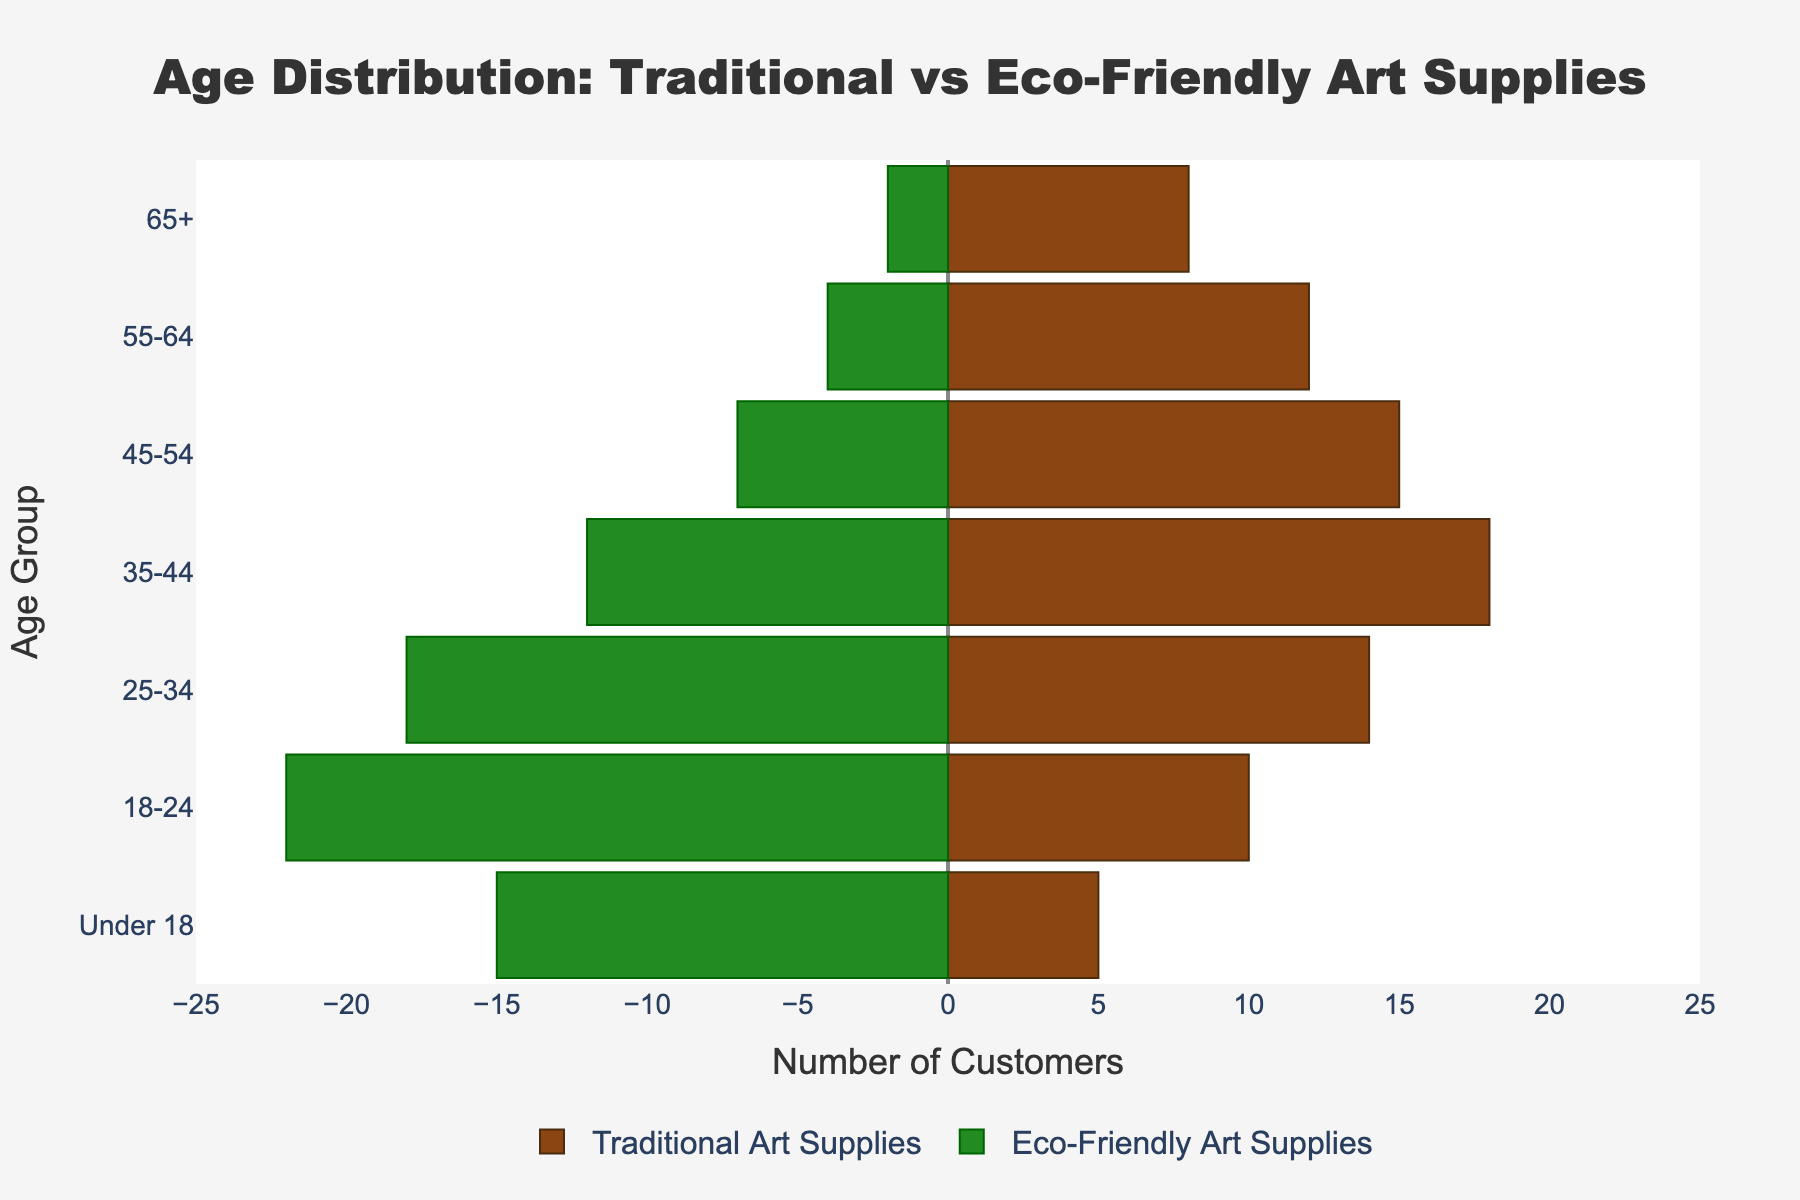What's the title of the figure? The title is centered at the top of the figure and is typically the most prominent text. It is a few words long, generally summarizes what the chart represents.
Answer: Age Distribution: Traditional vs Eco-Friendly Art Supplies How many customers under 18 buy eco-friendly art supplies? The figure shows a bar on the left side for the age group under 18. The height of the bar corresponds to the number of customers in that age group.
Answer: 15 Which age group has the most traditional art supply customers? We need to compare the lengths of the bars on the right side of the figure for different age groups and identify the longest one.
Answer: 35-44 How many more eco-friendly art supply customers are there in the 25-34 age group compared to traditional art supply customers? From the figure, identify the lengths of the bars for both eco-friendly and traditional art supplies in the 25-34 age group. Then, subtract the length of the traditional bar from the length of the eco-friendly bar.
Answer: 4 What is the sum of customers aged 55 and older for traditional art supplies? We add the number of customers in the 55-64 and 65+ age groups for traditional art supplies by summing their respective bars' lengths.
Answer: 20 How does customer distribution differ between traditional and eco-friendly art supplies for the 18-24 age group? Look at the lengths of the bars for the 18-24 age group on both sides of the figure. Compare the numbers and note the difference.
Answer: There are more eco-friendly art supply customers (22) than traditional art supply customers (10) Which age group shows the smallest difference in customer numbers between traditional and eco-friendly art supplies? Calculate the absolute difference between the lengths of traditional and eco-friendly bars for each age group, then determine the smallest difference.
Answer: 35-44 (6) What is the overall trend in customer preference for traditional vs eco-friendly art supplies as age increases? Observe the trend in bar lengths on both sides of the chart as the age groups move from younger to older. Note whether one type of supply consistently has more customers.
Answer: Traditional art supplies have more customers in older age groups, while eco-friendly art supplies have more customers in younger age groups What is the total number of traditional art supply customers across all age groups? Add the lengths of all bars on the right side of the figure to get the total number of traditional art supply customers.
Answer: 82 How does the number of customers aged 45-54 buying eco-friendly art supplies compare to those buying traditional art supplies? Compare the lengths of the bars for eco-friendly and traditional art supplies in the 45-54 age group and note which is longer and by how much.
Answer: Traditional art supply customers (15) outnumber eco-friendly art supply customers (7) 